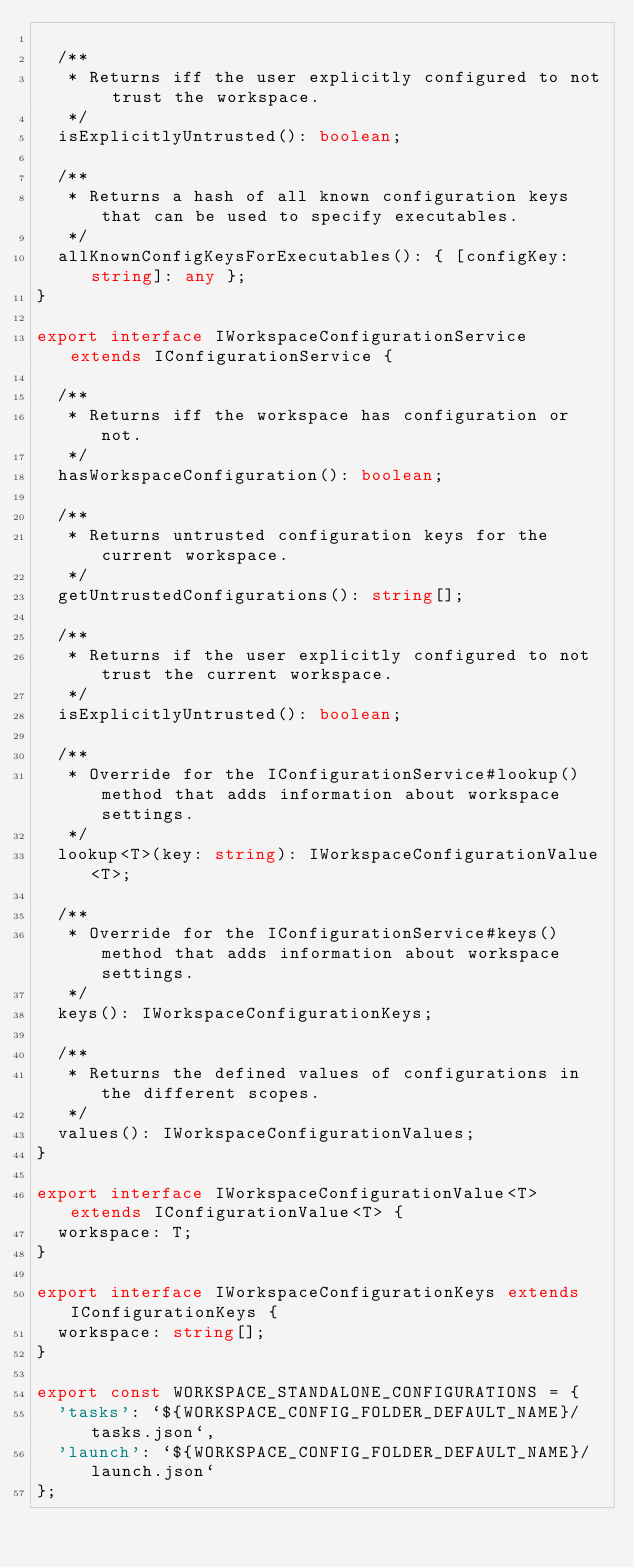Convert code to text. <code><loc_0><loc_0><loc_500><loc_500><_TypeScript_>
	/**
	 * Returns iff the user explicitly configured to not trust the workspace.
	 */
	isExplicitlyUntrusted(): boolean;

	/**
	 * Returns a hash of all known configuration keys that can be used to specify executables.
	 */
	allKnownConfigKeysForExecutables(): { [configKey: string]: any };
}

export interface IWorkspaceConfigurationService extends IConfigurationService {

	/**
	 * Returns iff the workspace has configuration or not.
	 */
	hasWorkspaceConfiguration(): boolean;

	/**
	 * Returns untrusted configuration keys for the current workspace.
	 */
	getUntrustedConfigurations(): string[];

	/**
	 * Returns if the user explicitly configured to not trust the current workspace.
	 */
	isExplicitlyUntrusted(): boolean;

	/**
	 * Override for the IConfigurationService#lookup() method that adds information about workspace settings.
	 */
	lookup<T>(key: string): IWorkspaceConfigurationValue<T>;

	/**
	 * Override for the IConfigurationService#keys() method that adds information about workspace settings.
	 */
	keys(): IWorkspaceConfigurationKeys;

	/**
	 * Returns the defined values of configurations in the different scopes.
	 */
	values(): IWorkspaceConfigurationValues;
}

export interface IWorkspaceConfigurationValue<T> extends IConfigurationValue<T> {
	workspace: T;
}

export interface IWorkspaceConfigurationKeys extends IConfigurationKeys {
	workspace: string[];
}

export const WORKSPACE_STANDALONE_CONFIGURATIONS = {
	'tasks': `${WORKSPACE_CONFIG_FOLDER_DEFAULT_NAME}/tasks.json`,
	'launch': `${WORKSPACE_CONFIG_FOLDER_DEFAULT_NAME}/launch.json`
};</code> 